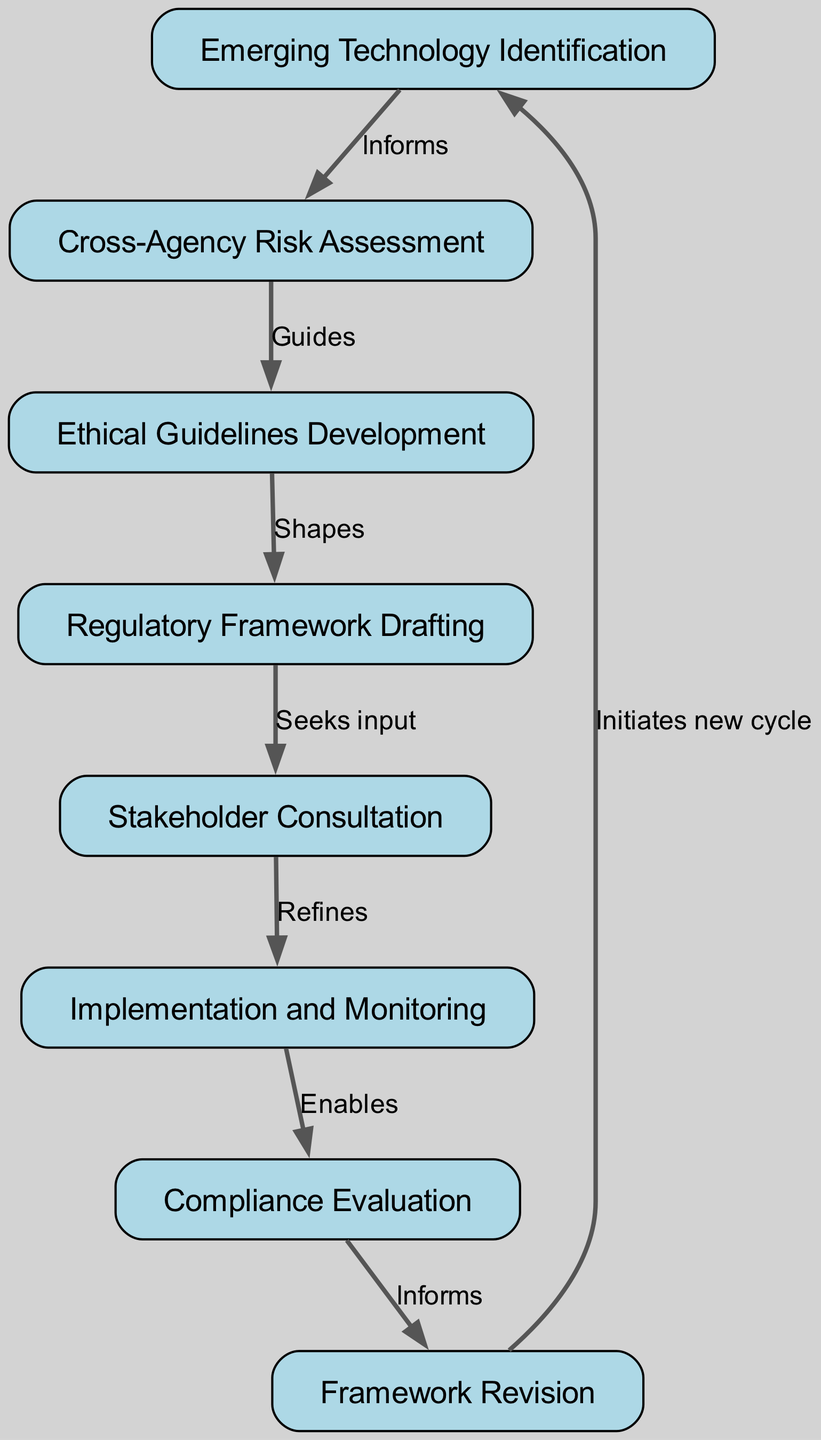What is the first step in the regulatory compliance lifecycle? The first step, identified in the diagram, is "Emerging Technology Identification." This is the starting point of the lifecycle where new technologies are recognized.
Answer: Emerging Technology Identification How many nodes are in the diagram? By counting all the labeled boxes in the diagram representing different stages, there are a total of eight nodes listed.
Answer: 8 Which node follows "Cross-Agency Risk Assessment"? Looking at the arrows connecting the nodes, "Cross-Agency Risk Assessment" is directly connected to "Ethical Guidelines Development," which is the next step in the process.
Answer: Ethical Guidelines Development What relationship does "Implementation and Monitoring" have with the "Compliance Evaluation"? The edge connecting these nodes indicates that "Implementation and Monitoring" enables "Compliance Evaluation," showing that effective implementation is a prerequisite for evaluating compliance.
Answer: Enables What action does "Regulatory Framework Drafting" seek after its development? The diagram shows an arrow from "Regulatory Framework Drafting" to "Stakeholder Consultation" indicating that it seeks input from stakeholders as the next step in the process.
Answer: Seeks input How many edges are present in the diagram? By reviewing the connections between nodes, there are a total of seven edges that represent the relationships among the nodes in the lifecycle.
Answer: 7 What initiates the new cycle in the regulatory compliance lifecycle? According to the flow of the diagram, "Framework Revision" leads back to "Emerging Technology Identification," which indicates that the new cycle starts after revisions are made.
Answer: Initiates new cycle How does "Ethical Guidelines Development" impact "Regulatory Framework Drafting"? The diagram indicates that "Ethical Guidelines Development" shapes "Regulatory Framework Drafting," meaning that the guidelines developed earlier influence the drafting of the regulatory framework.
Answer: Shapes 